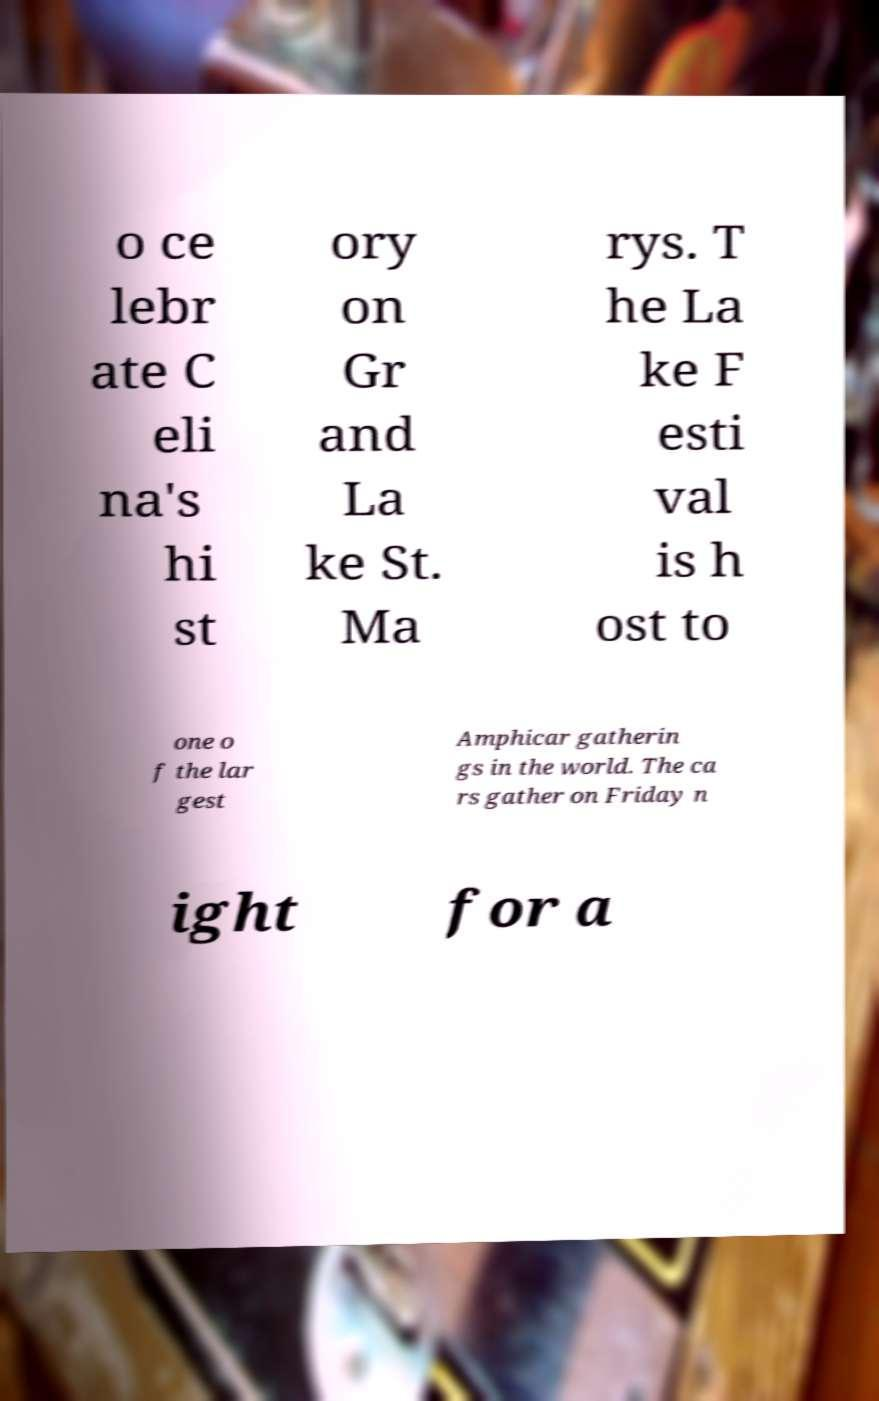There's text embedded in this image that I need extracted. Can you transcribe it verbatim? o ce lebr ate C eli na's hi st ory on Gr and La ke St. Ma rys. T he La ke F esti val is h ost to one o f the lar gest Amphicar gatherin gs in the world. The ca rs gather on Friday n ight for a 